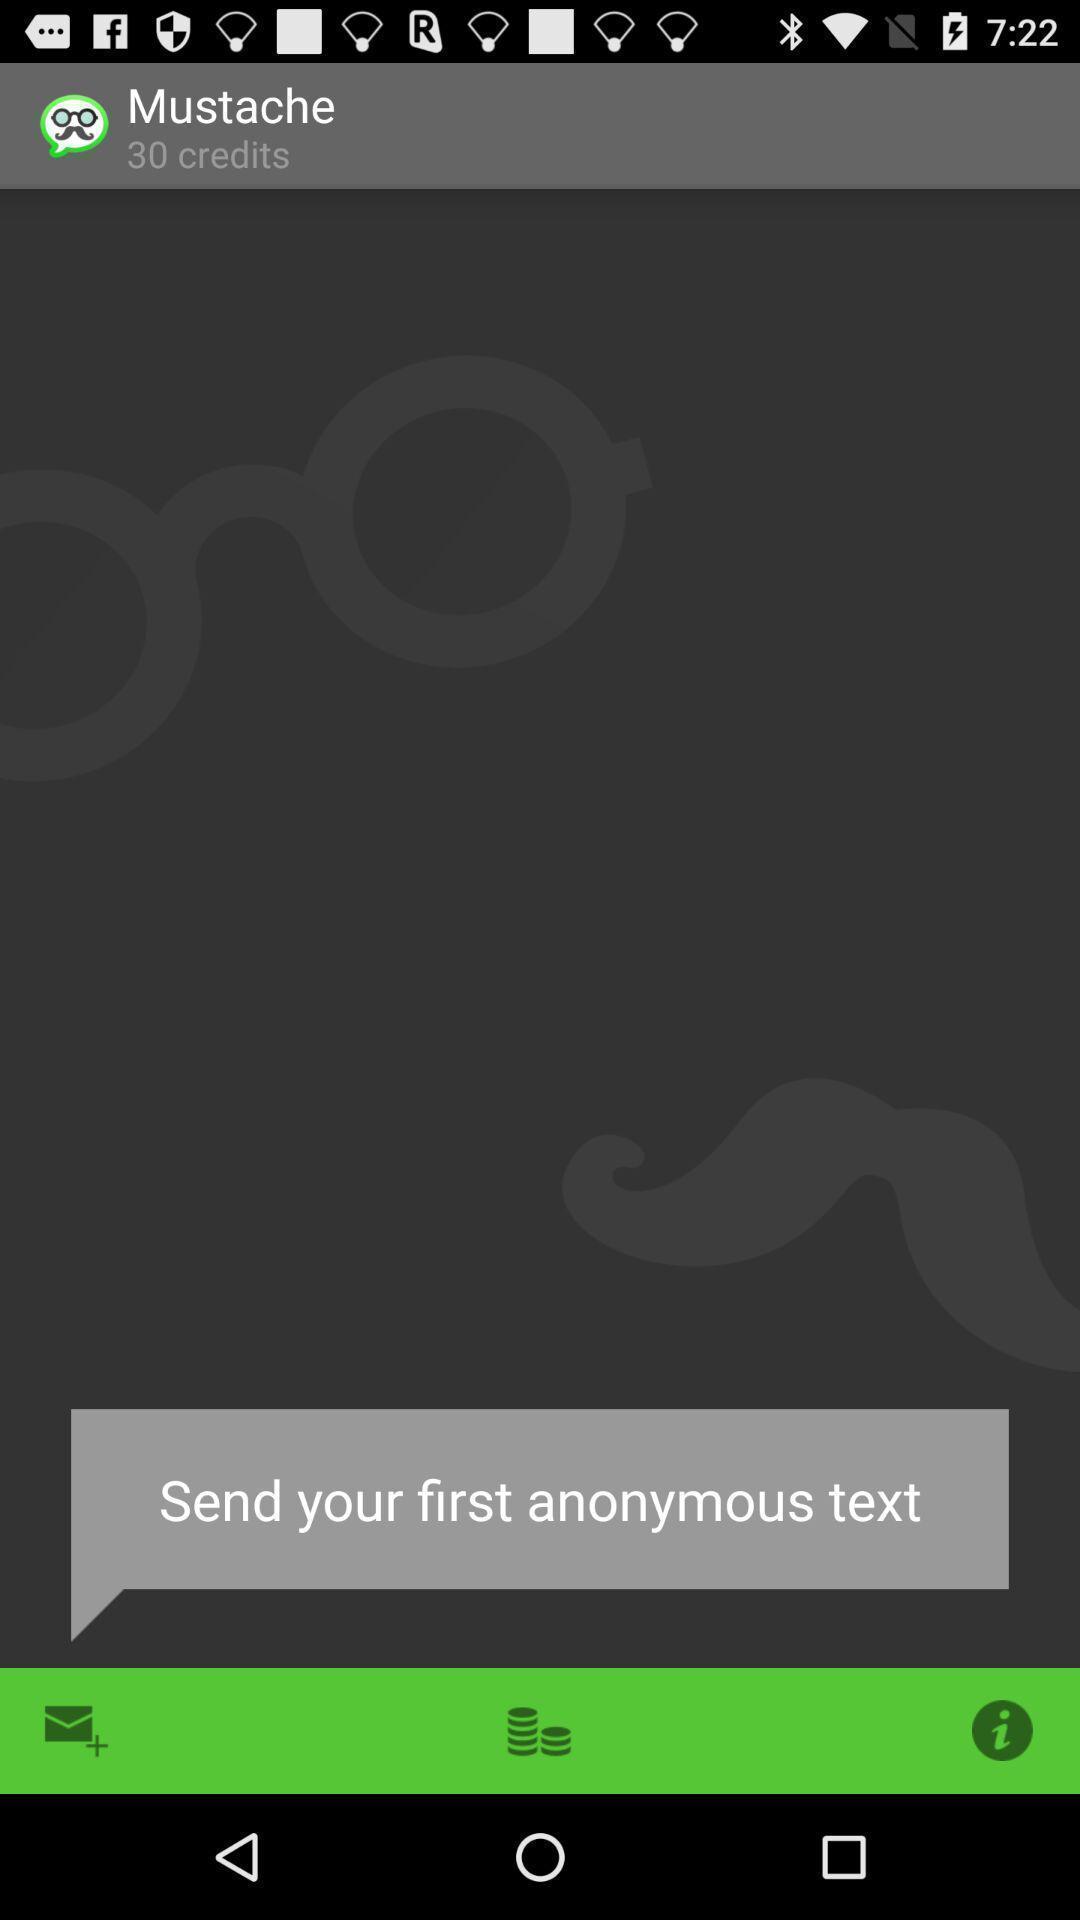What can you discern from this picture? Screen displaying various tools in app. 